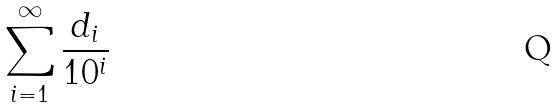Convert formula to latex. <formula><loc_0><loc_0><loc_500><loc_500>\sum _ { i = 1 } ^ { \infty } \frac { d _ { i } } { 1 0 ^ { i } }</formula> 